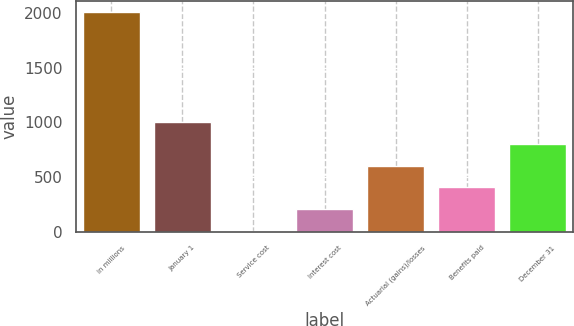Convert chart to OTSL. <chart><loc_0><loc_0><loc_500><loc_500><bar_chart><fcel>in millions<fcel>January 1<fcel>Service cost<fcel>Interest cost<fcel>Actuarial (gains)/losses<fcel>Benefits paid<fcel>December 31<nl><fcel>2011<fcel>1005.75<fcel>0.5<fcel>201.55<fcel>603.65<fcel>402.6<fcel>804.7<nl></chart> 